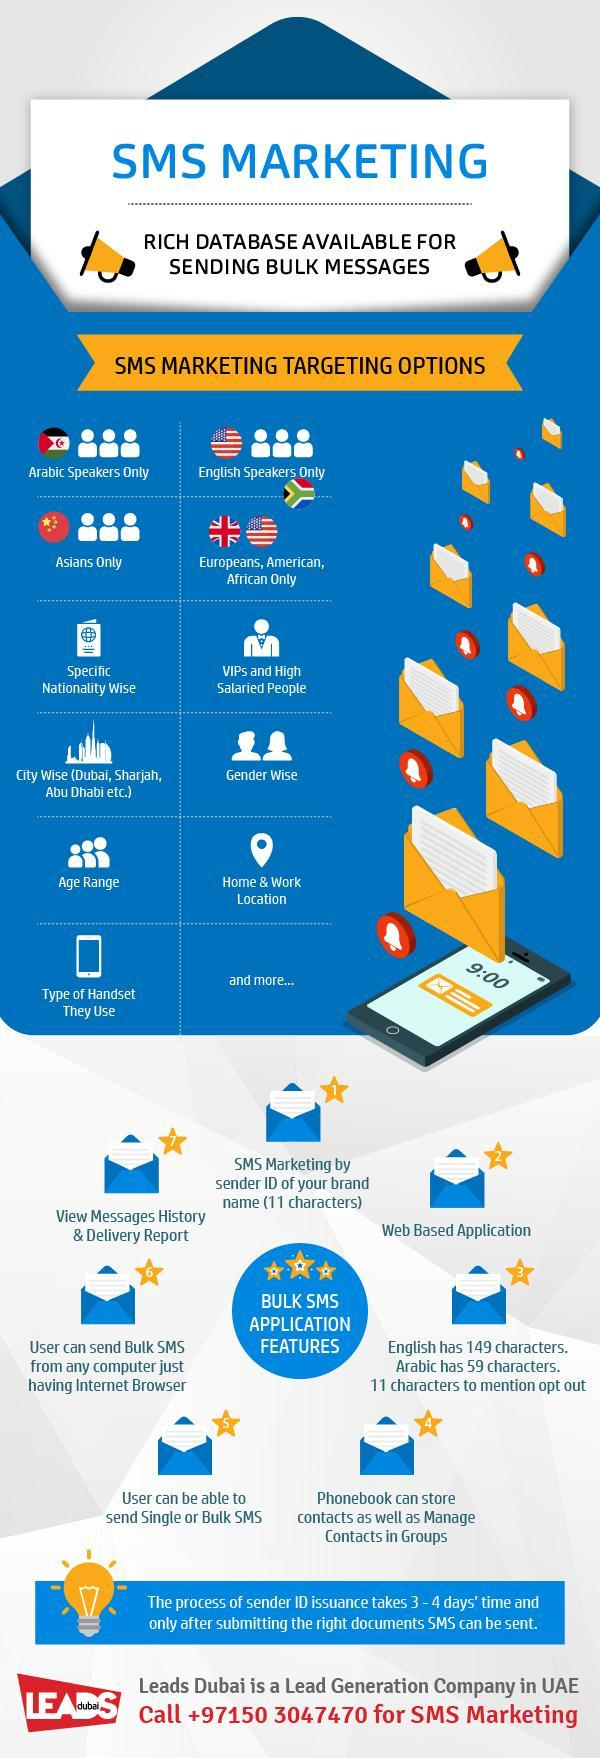How many SMS marketing targeting options mentioned in this infographic?
Answer the question with a short phrase. 11 How many bell icons are in this infographic? 7 How many public announcement systems are in this infographic? 2 How many American flags are in this infographic? 2 What is the time mentioned on the phone? 9:00 